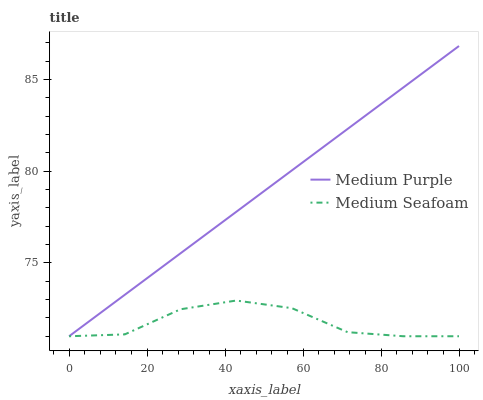Does Medium Seafoam have the minimum area under the curve?
Answer yes or no. Yes. Does Medium Purple have the maximum area under the curve?
Answer yes or no. Yes. Does Medium Seafoam have the maximum area under the curve?
Answer yes or no. No. Is Medium Purple the smoothest?
Answer yes or no. Yes. Is Medium Seafoam the roughest?
Answer yes or no. Yes. Is Medium Seafoam the smoothest?
Answer yes or no. No. Does Medium Purple have the lowest value?
Answer yes or no. Yes. Does Medium Purple have the highest value?
Answer yes or no. Yes. Does Medium Seafoam have the highest value?
Answer yes or no. No. Does Medium Seafoam intersect Medium Purple?
Answer yes or no. Yes. Is Medium Seafoam less than Medium Purple?
Answer yes or no. No. Is Medium Seafoam greater than Medium Purple?
Answer yes or no. No. 